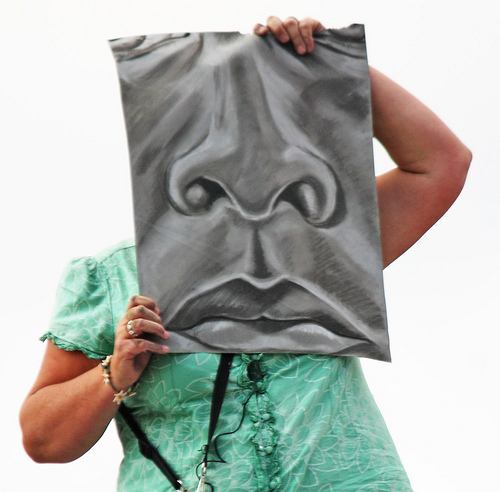<image>
Is the drawing behind the person? No. The drawing is not behind the person. From this viewpoint, the drawing appears to be positioned elsewhere in the scene. 